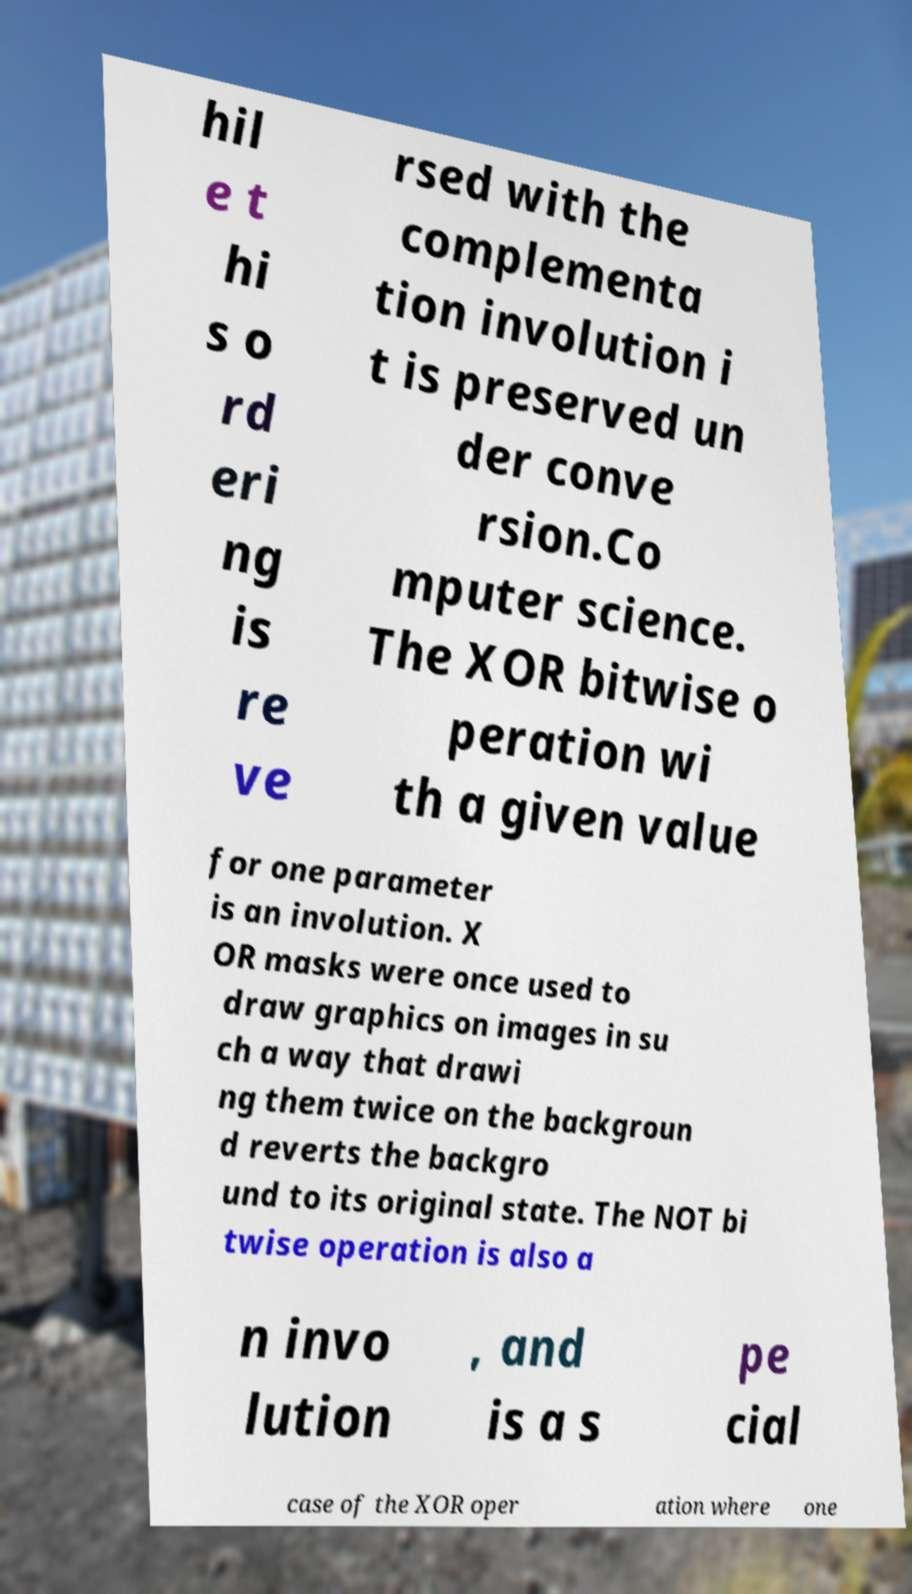Can you read and provide the text displayed in the image?This photo seems to have some interesting text. Can you extract and type it out for me? hil e t hi s o rd eri ng is re ve rsed with the complementa tion involution i t is preserved un der conve rsion.Co mputer science. The XOR bitwise o peration wi th a given value for one parameter is an involution. X OR masks were once used to draw graphics on images in su ch a way that drawi ng them twice on the backgroun d reverts the backgro und to its original state. The NOT bi twise operation is also a n invo lution , and is a s pe cial case of the XOR oper ation where one 